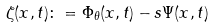Convert formula to latex. <formula><loc_0><loc_0><loc_500><loc_500>\zeta ( x , t ) \colon = \Phi _ { \theta } ( x , t ) - s \Psi ( x , t )</formula> 